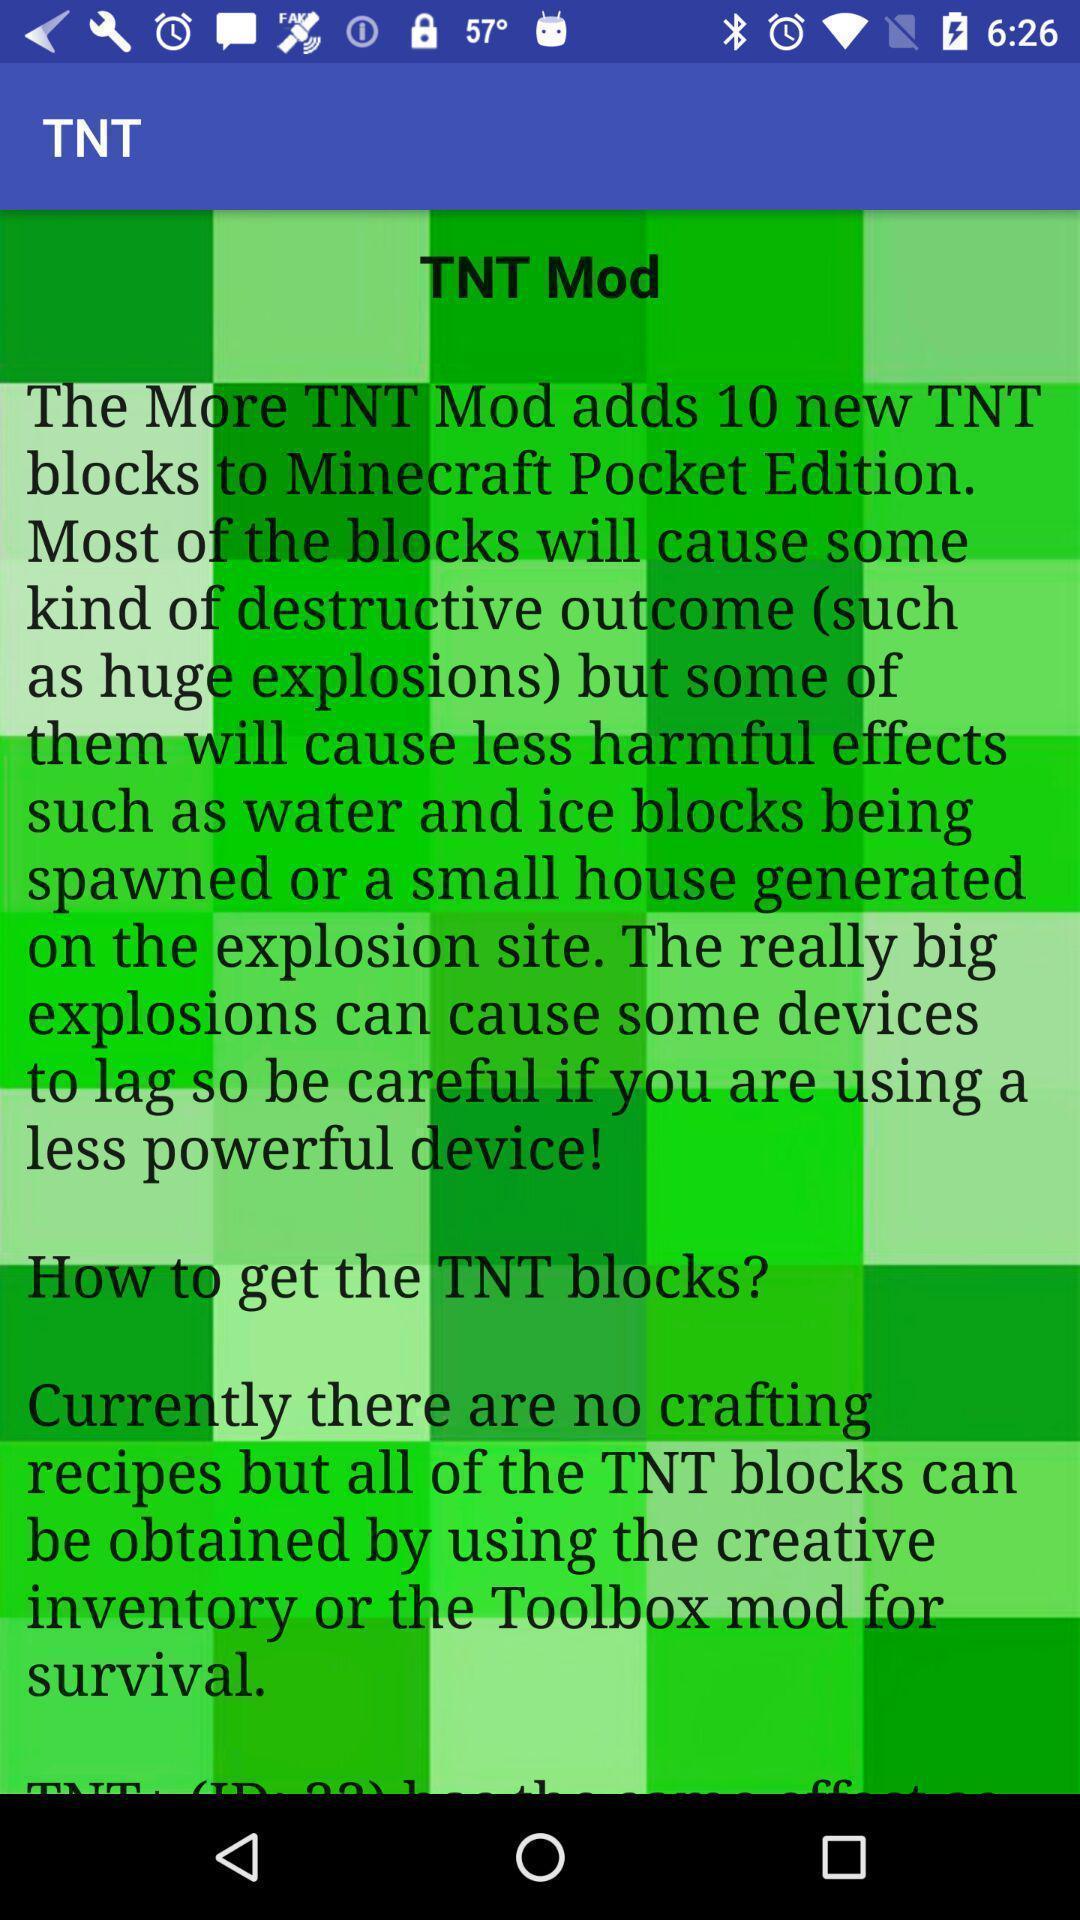What is the overall content of this screenshot? Tnt mode of the tnt app. 